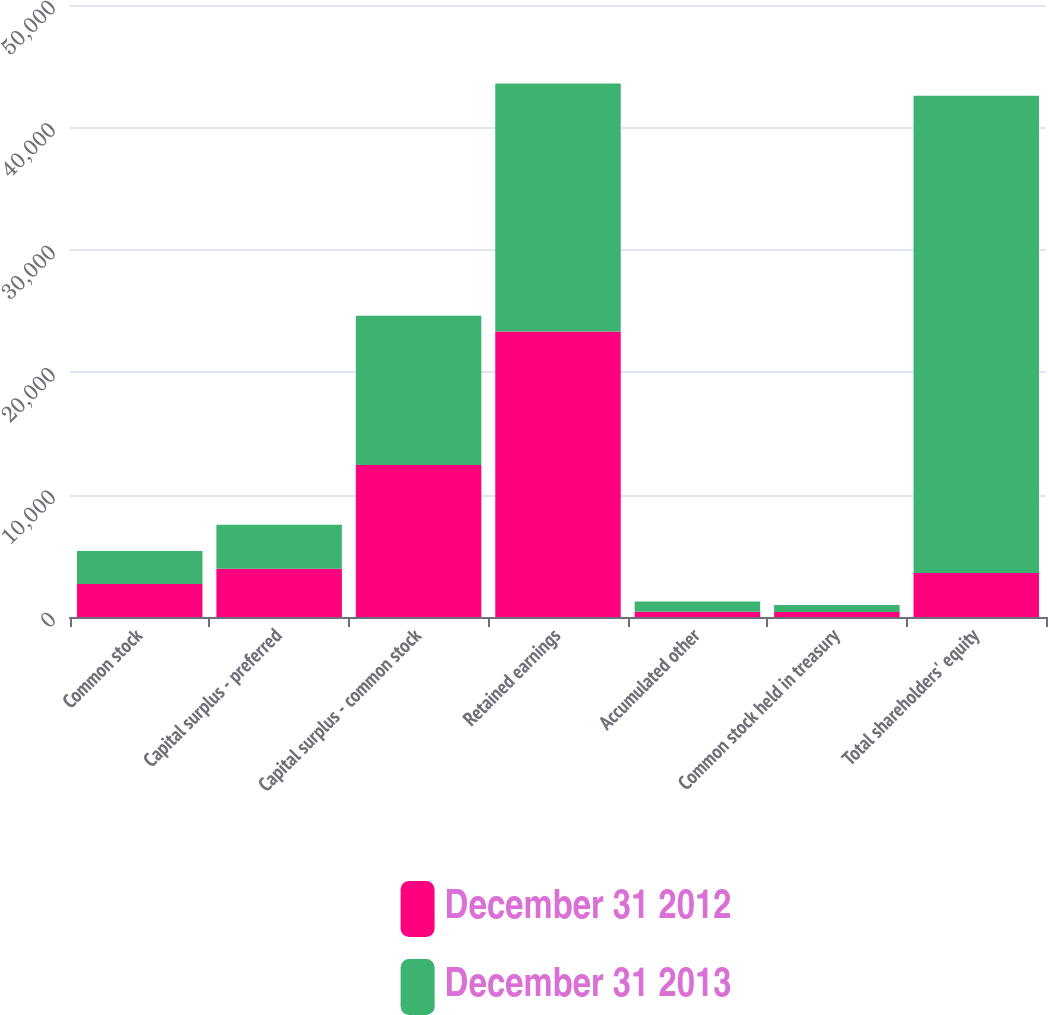Convert chart. <chart><loc_0><loc_0><loc_500><loc_500><stacked_bar_chart><ecel><fcel>Common stock<fcel>Capital surplus - preferred<fcel>Capital surplus - common stock<fcel>Retained earnings<fcel>Accumulated other<fcel>Common stock held in treasury<fcel>Total shareholders' equity<nl><fcel>December 31 2012<fcel>2698<fcel>3941<fcel>12416<fcel>23325<fcel>436<fcel>408<fcel>3590<nl><fcel>December 31 2013<fcel>2690<fcel>3590<fcel>12193<fcel>20265<fcel>834<fcel>569<fcel>39003<nl></chart> 